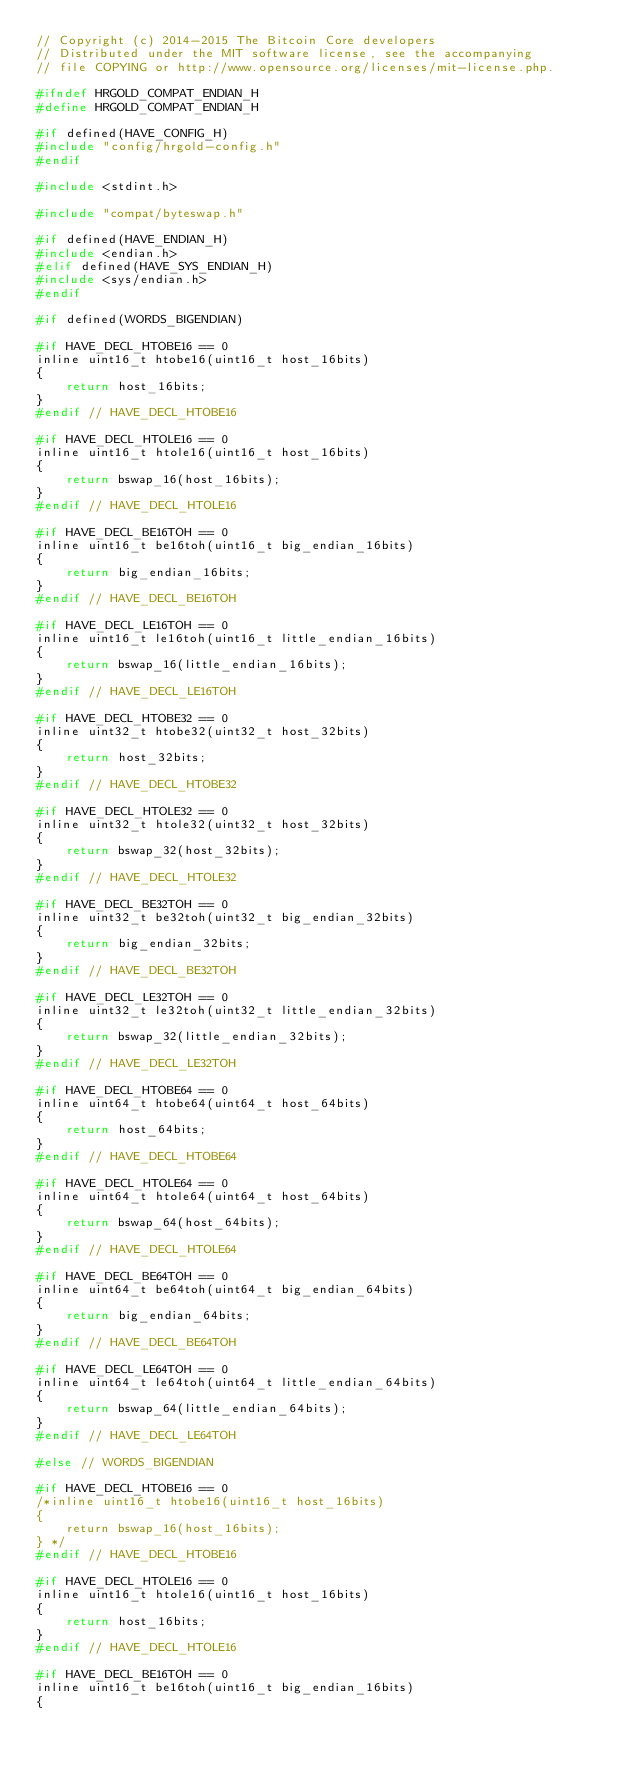<code> <loc_0><loc_0><loc_500><loc_500><_C_>// Copyright (c) 2014-2015 The Bitcoin Core developers
// Distributed under the MIT software license, see the accompanying
// file COPYING or http://www.opensource.org/licenses/mit-license.php.

#ifndef HRGOLD_COMPAT_ENDIAN_H
#define HRGOLD_COMPAT_ENDIAN_H

#if defined(HAVE_CONFIG_H)
#include "config/hrgold-config.h"
#endif

#include <stdint.h>

#include "compat/byteswap.h"

#if defined(HAVE_ENDIAN_H)
#include <endian.h>
#elif defined(HAVE_SYS_ENDIAN_H)
#include <sys/endian.h>
#endif

#if defined(WORDS_BIGENDIAN)

#if HAVE_DECL_HTOBE16 == 0
inline uint16_t htobe16(uint16_t host_16bits)
{
    return host_16bits;
}
#endif // HAVE_DECL_HTOBE16

#if HAVE_DECL_HTOLE16 == 0
inline uint16_t htole16(uint16_t host_16bits)
{
    return bswap_16(host_16bits);
}
#endif // HAVE_DECL_HTOLE16

#if HAVE_DECL_BE16TOH == 0
inline uint16_t be16toh(uint16_t big_endian_16bits)
{
    return big_endian_16bits;
}
#endif // HAVE_DECL_BE16TOH

#if HAVE_DECL_LE16TOH == 0
inline uint16_t le16toh(uint16_t little_endian_16bits)
{
    return bswap_16(little_endian_16bits);
}
#endif // HAVE_DECL_LE16TOH

#if HAVE_DECL_HTOBE32 == 0
inline uint32_t htobe32(uint32_t host_32bits)
{
    return host_32bits;
}
#endif // HAVE_DECL_HTOBE32

#if HAVE_DECL_HTOLE32 == 0
inline uint32_t htole32(uint32_t host_32bits)
{
    return bswap_32(host_32bits);
}
#endif // HAVE_DECL_HTOLE32

#if HAVE_DECL_BE32TOH == 0
inline uint32_t be32toh(uint32_t big_endian_32bits)
{
    return big_endian_32bits;
}
#endif // HAVE_DECL_BE32TOH

#if HAVE_DECL_LE32TOH == 0
inline uint32_t le32toh(uint32_t little_endian_32bits)
{
    return bswap_32(little_endian_32bits);
}
#endif // HAVE_DECL_LE32TOH

#if HAVE_DECL_HTOBE64 == 0
inline uint64_t htobe64(uint64_t host_64bits)
{
    return host_64bits;
}
#endif // HAVE_DECL_HTOBE64

#if HAVE_DECL_HTOLE64 == 0
inline uint64_t htole64(uint64_t host_64bits)
{
    return bswap_64(host_64bits);
}
#endif // HAVE_DECL_HTOLE64

#if HAVE_DECL_BE64TOH == 0
inline uint64_t be64toh(uint64_t big_endian_64bits)
{
    return big_endian_64bits;
}
#endif // HAVE_DECL_BE64TOH

#if HAVE_DECL_LE64TOH == 0
inline uint64_t le64toh(uint64_t little_endian_64bits)
{
    return bswap_64(little_endian_64bits);
}
#endif // HAVE_DECL_LE64TOH

#else // WORDS_BIGENDIAN

#if HAVE_DECL_HTOBE16 == 0
/*inline uint16_t htobe16(uint16_t host_16bits)
{
    return bswap_16(host_16bits);
} */
#endif // HAVE_DECL_HTOBE16

#if HAVE_DECL_HTOLE16 == 0
inline uint16_t htole16(uint16_t host_16bits)
{
    return host_16bits;
}
#endif // HAVE_DECL_HTOLE16

#if HAVE_DECL_BE16TOH == 0
inline uint16_t be16toh(uint16_t big_endian_16bits)
{</code> 